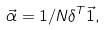<formula> <loc_0><loc_0><loc_500><loc_500>\vec { \alpha } = 1 / N \delta ^ { T } \vec { 1 } ,</formula> 